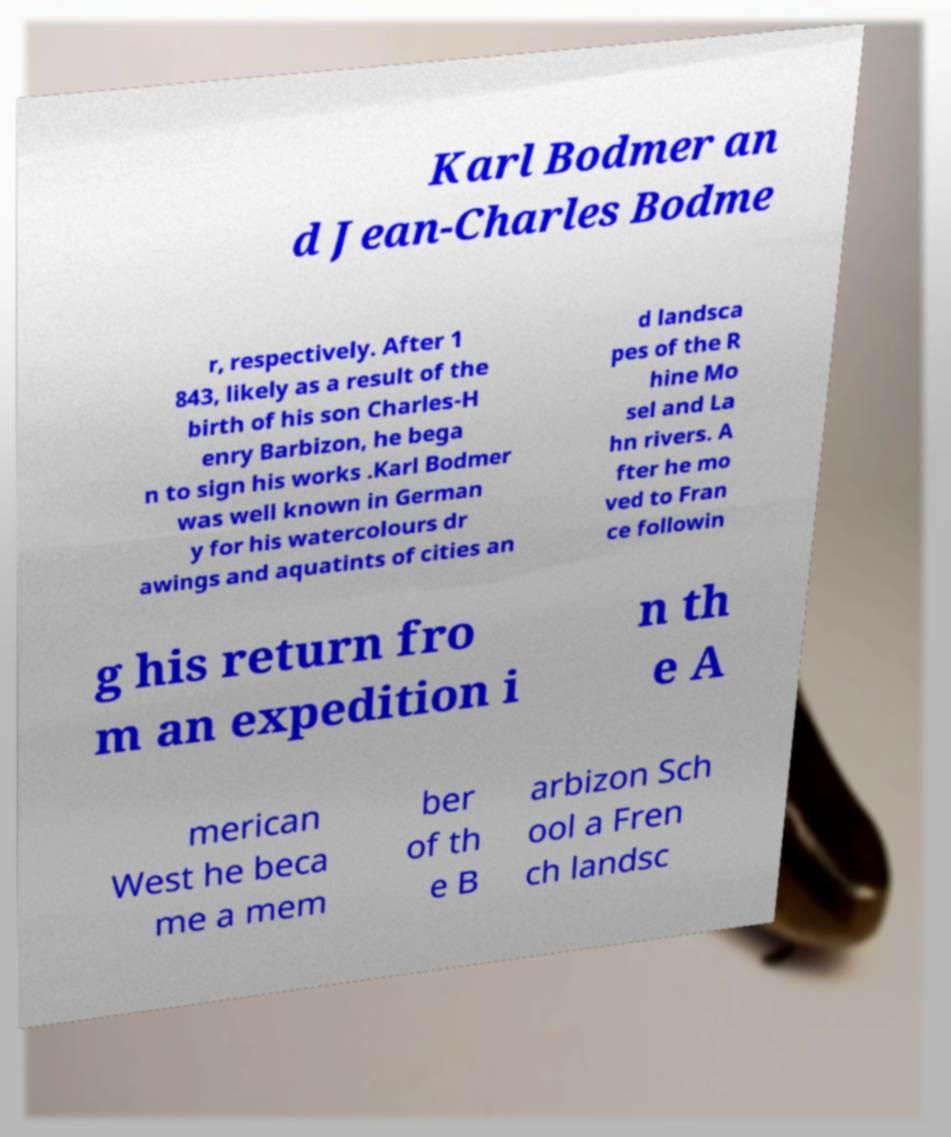Please read and relay the text visible in this image. What does it say? Karl Bodmer an d Jean-Charles Bodme r, respectively. After 1 843, likely as a result of the birth of his son Charles-H enry Barbizon, he bega n to sign his works .Karl Bodmer was well known in German y for his watercolours dr awings and aquatints of cities an d landsca pes of the R hine Mo sel and La hn rivers. A fter he mo ved to Fran ce followin g his return fro m an expedition i n th e A merican West he beca me a mem ber of th e B arbizon Sch ool a Fren ch landsc 